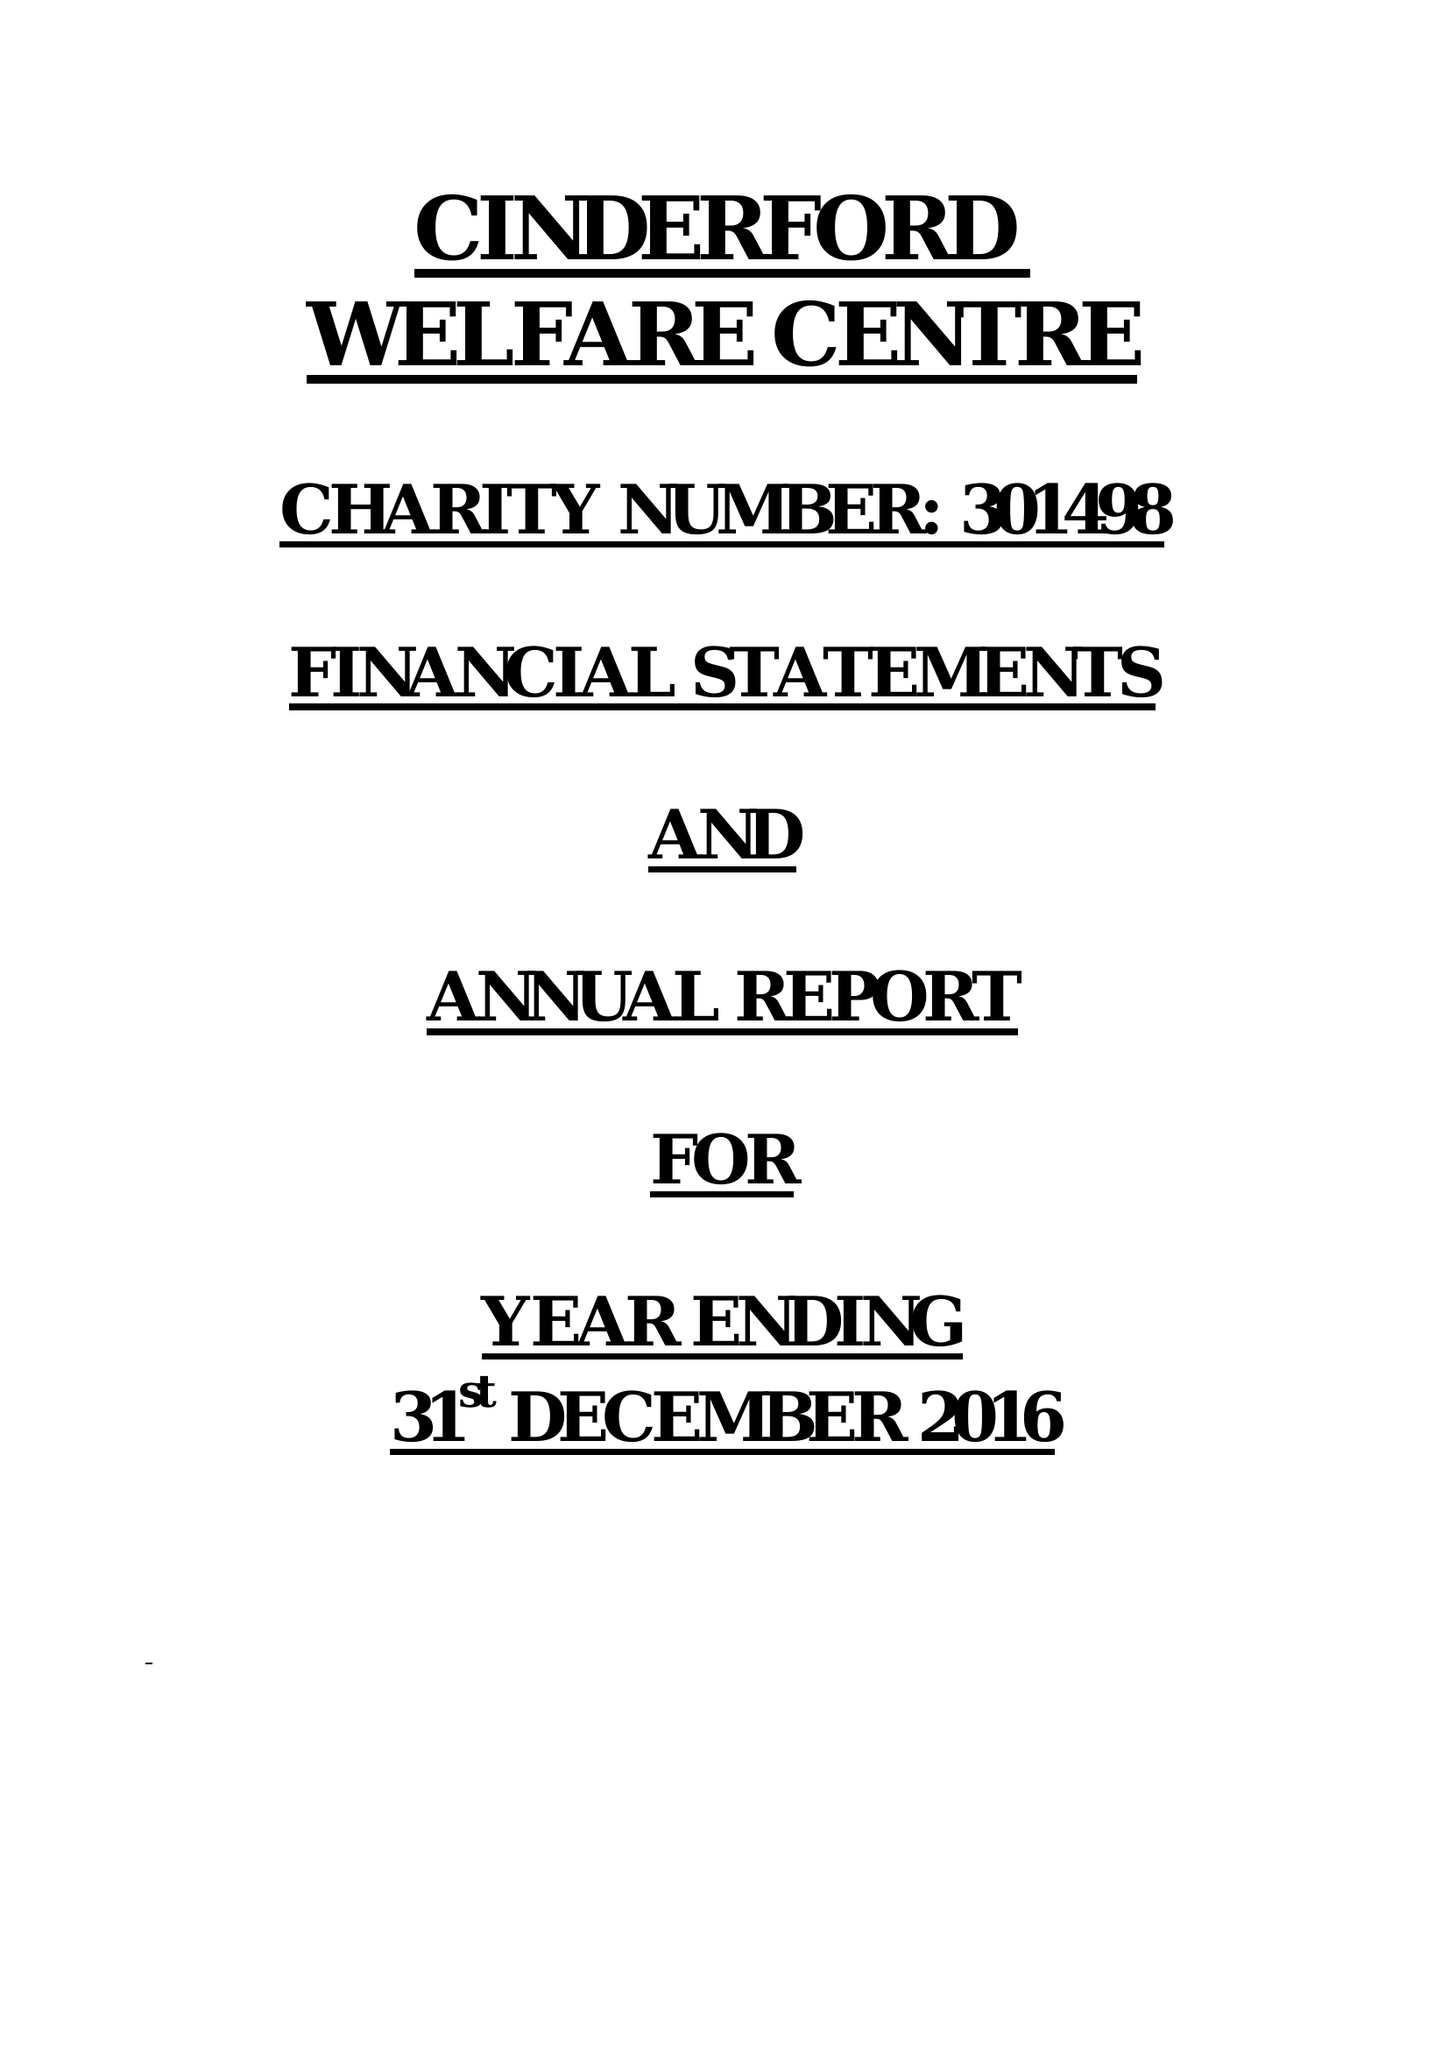What is the value for the income_annually_in_british_pounds?
Answer the question using a single word or phrase. 39064.00 